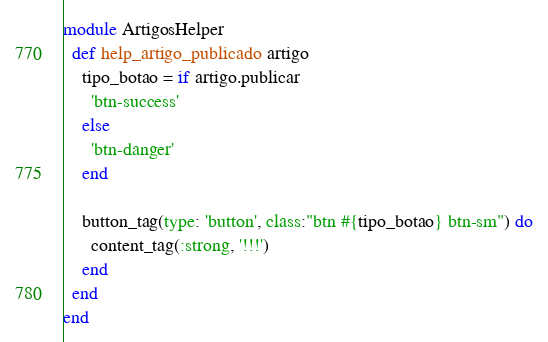Convert code to text. <code><loc_0><loc_0><loc_500><loc_500><_Ruby_>module ArtigosHelper
  def help_artigo_publicado artigo
    tipo_botao = if artigo.publicar 
      'btn-success'
    else
      'btn-danger'
    end

    button_tag(type: 'button', class:"btn #{tipo_botao} btn-sm") do
      content_tag(:strong, '!!!')
    end
  end
end
</code> 